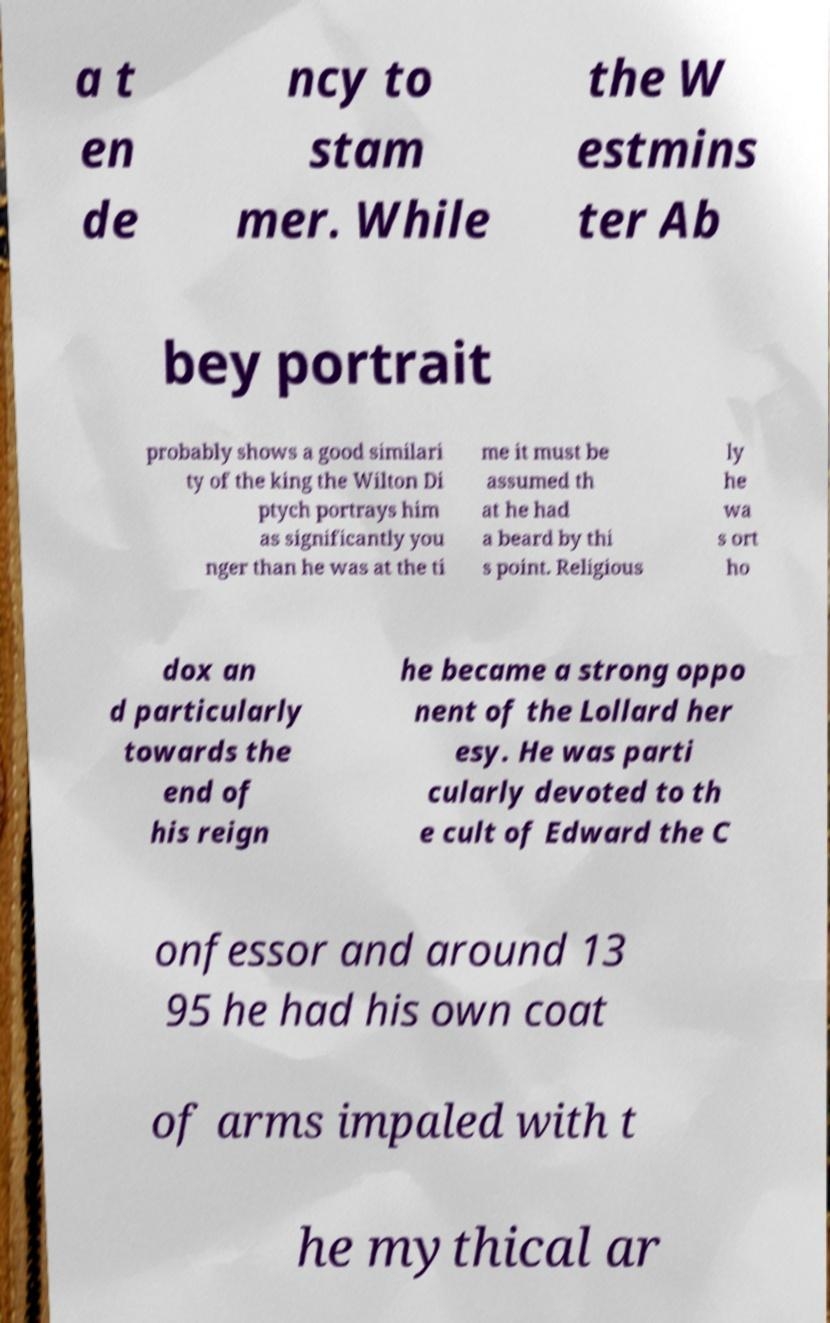I need the written content from this picture converted into text. Can you do that? a t en de ncy to stam mer. While the W estmins ter Ab bey portrait probably shows a good similari ty of the king the Wilton Di ptych portrays him as significantly you nger than he was at the ti me it must be assumed th at he had a beard by thi s point. Religious ly he wa s ort ho dox an d particularly towards the end of his reign he became a strong oppo nent of the Lollard her esy. He was parti cularly devoted to th e cult of Edward the C onfessor and around 13 95 he had his own coat of arms impaled with t he mythical ar 